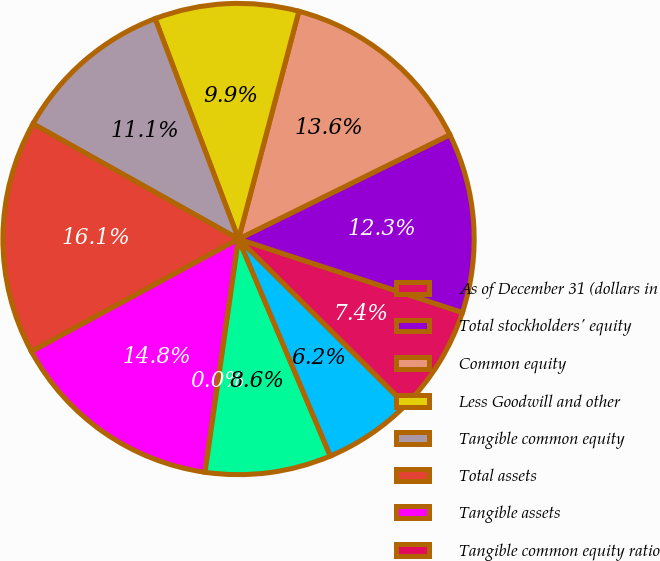Convert chart to OTSL. <chart><loc_0><loc_0><loc_500><loc_500><pie_chart><fcel>As of December 31 (dollars in<fcel>Total stockholders' equity<fcel>Common equity<fcel>Less Goodwill and other<fcel>Tangible common equity<fcel>Total assets<fcel>Tangible assets<fcel>Tangible common equity ratio<fcel>As of December 31 (in millions<fcel>Common shares issued<nl><fcel>7.41%<fcel>12.34%<fcel>13.58%<fcel>9.88%<fcel>11.11%<fcel>16.05%<fcel>14.81%<fcel>0.0%<fcel>8.64%<fcel>6.17%<nl></chart> 